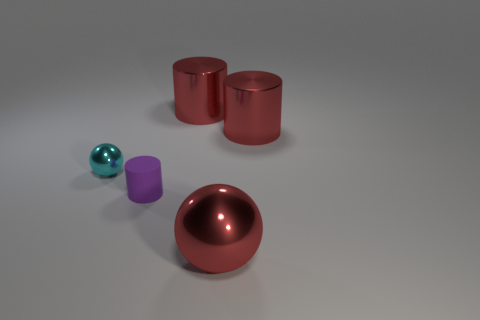What number of big red things are behind the tiny shiny object and in front of the tiny purple rubber cylinder?
Your response must be concise. 0. The small thing that is left of the small purple cylinder has what shape?
Ensure brevity in your answer.  Sphere. How many red metallic cylinders have the same size as the rubber cylinder?
Provide a short and direct response. 0. There is a metal ball behind the purple rubber object; does it have the same color as the big metal sphere?
Your answer should be very brief. No. What is the material of the cylinder that is both left of the red metal ball and behind the small purple object?
Ensure brevity in your answer.  Metal. Is the number of brown rubber balls greater than the number of tiny cylinders?
Make the answer very short. No. There is a cylinder that is on the left side of the big metal thing that is left of the metal sphere in front of the small metal ball; what color is it?
Your answer should be very brief. Purple. Do the small ball that is left of the tiny purple rubber object and the small cylinder have the same material?
Give a very brief answer. No. Is there a shiny cube that has the same color as the small sphere?
Offer a terse response. No. Are any rubber cylinders visible?
Provide a short and direct response. Yes. 